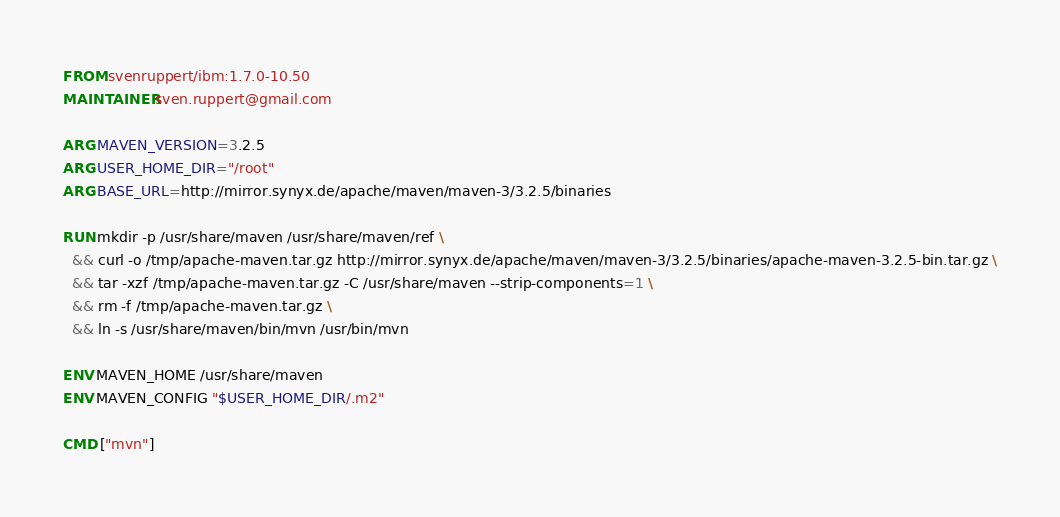Convert code to text. <code><loc_0><loc_0><loc_500><loc_500><_Dockerfile_>FROM svenruppert/ibm:1.7.0-10.50
MAINTAINER sven.ruppert@gmail.com

ARG MAVEN_VERSION=3.2.5
ARG USER_HOME_DIR="/root"
ARG BASE_URL=http://mirror.synyx.de/apache/maven/maven-3/3.2.5/binaries

RUN mkdir -p /usr/share/maven /usr/share/maven/ref \
  && curl -o /tmp/apache-maven.tar.gz http://mirror.synyx.de/apache/maven/maven-3/3.2.5/binaries/apache-maven-3.2.5-bin.tar.gz \
  && tar -xzf /tmp/apache-maven.tar.gz -C /usr/share/maven --strip-components=1 \
  && rm -f /tmp/apache-maven.tar.gz \
  && ln -s /usr/share/maven/bin/mvn /usr/bin/mvn

ENV MAVEN_HOME /usr/share/maven
ENV MAVEN_CONFIG "$USER_HOME_DIR/.m2"

CMD ["mvn"]</code> 